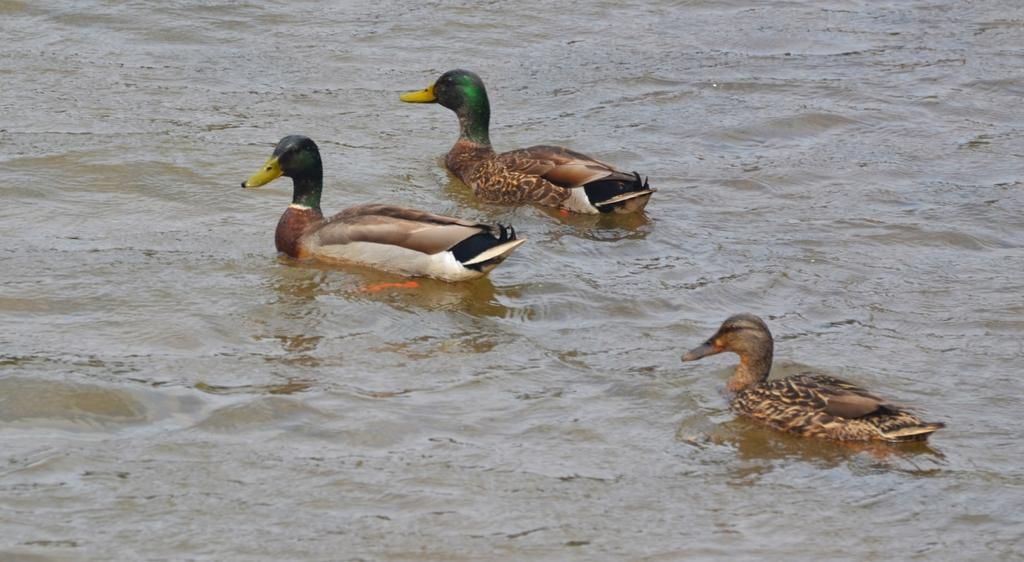What animals are in the center of the image? There are ducks in the center of the image. Where are the ducks located? The ducks are on the water. What type of flame can be seen on the ducks in the image? There is no flame present on the ducks in the image. What kind of test is being conducted on the ducks in the image? There is no test being conducted on the ducks in the image. 